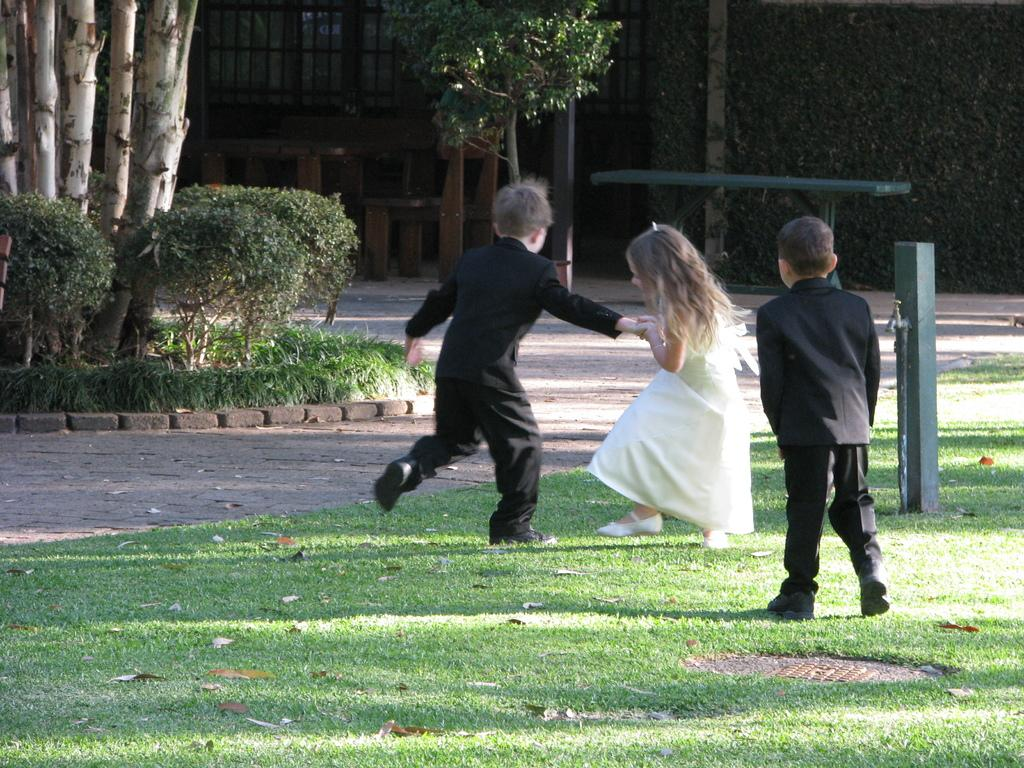What are the kids in the image doing? The kids are playing in the image. Where are the kids playing? The kids are playing on the ground. What can be seen attached to a pole in the image? There is a tap attached to a pole in the image. What type of natural elements can be seen in the background of the image? There are trees and plants in the background of the image. What type of seating is visible in the background of the image? There is a bench in the background of the image. What type of structure is visible in the background of the image? There is a building in the background of the image. What type of toy can be seen flying in the image? There is no toy visible in the image, let alone one that is flying. 